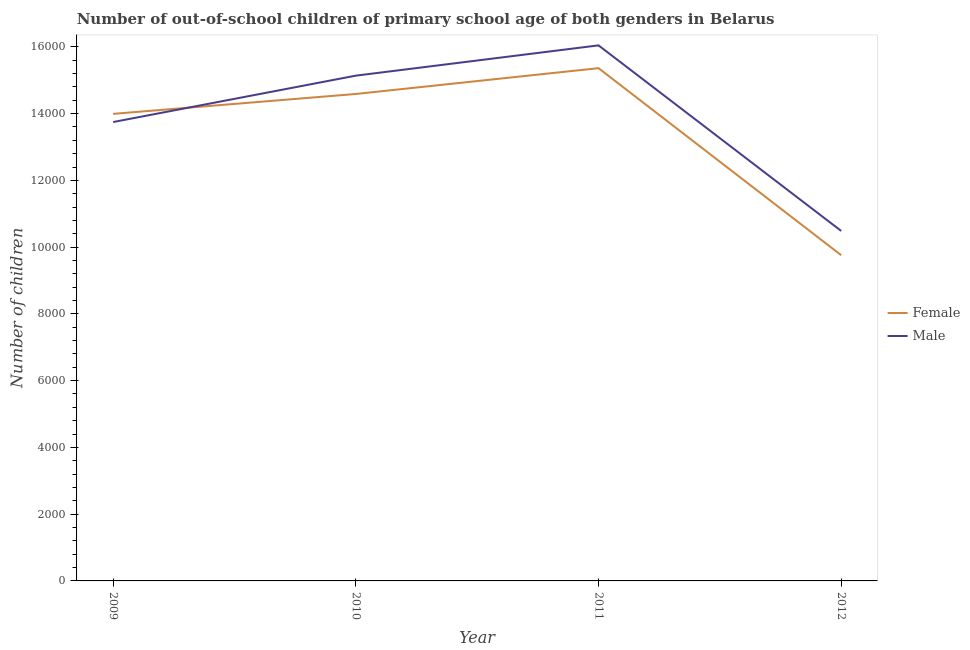Does the line corresponding to number of female out-of-school students intersect with the line corresponding to number of male out-of-school students?
Your response must be concise. Yes. What is the number of male out-of-school students in 2009?
Your response must be concise. 1.37e+04. Across all years, what is the maximum number of male out-of-school students?
Your response must be concise. 1.60e+04. Across all years, what is the minimum number of female out-of-school students?
Keep it short and to the point. 9758. In which year was the number of female out-of-school students maximum?
Ensure brevity in your answer.  2011. In which year was the number of female out-of-school students minimum?
Offer a terse response. 2012. What is the total number of female out-of-school students in the graph?
Your response must be concise. 5.37e+04. What is the difference between the number of male out-of-school students in 2011 and that in 2012?
Give a very brief answer. 5559. What is the difference between the number of female out-of-school students in 2009 and the number of male out-of-school students in 2010?
Your response must be concise. -1145. What is the average number of female out-of-school students per year?
Your answer should be very brief. 1.34e+04. In the year 2010, what is the difference between the number of female out-of-school students and number of male out-of-school students?
Keep it short and to the point. -549. What is the ratio of the number of male out-of-school students in 2011 to that in 2012?
Your answer should be very brief. 1.53. Is the number of male out-of-school students in 2009 less than that in 2012?
Give a very brief answer. No. Is the difference between the number of male out-of-school students in 2011 and 2012 greater than the difference between the number of female out-of-school students in 2011 and 2012?
Offer a terse response. No. What is the difference between the highest and the second highest number of male out-of-school students?
Provide a succinct answer. 907. What is the difference between the highest and the lowest number of male out-of-school students?
Provide a short and direct response. 5559. Is the sum of the number of female out-of-school students in 2009 and 2010 greater than the maximum number of male out-of-school students across all years?
Your response must be concise. Yes. Does the number of male out-of-school students monotonically increase over the years?
Offer a very short reply. No. Is the number of female out-of-school students strictly less than the number of male out-of-school students over the years?
Your answer should be very brief. No. How many lines are there?
Your answer should be very brief. 2. How many years are there in the graph?
Ensure brevity in your answer.  4. What is the difference between two consecutive major ticks on the Y-axis?
Provide a succinct answer. 2000. Are the values on the major ticks of Y-axis written in scientific E-notation?
Make the answer very short. No. Does the graph contain grids?
Your answer should be compact. No. How many legend labels are there?
Ensure brevity in your answer.  2. How are the legend labels stacked?
Provide a succinct answer. Vertical. What is the title of the graph?
Make the answer very short. Number of out-of-school children of primary school age of both genders in Belarus. What is the label or title of the X-axis?
Your response must be concise. Year. What is the label or title of the Y-axis?
Offer a terse response. Number of children. What is the Number of children of Female in 2009?
Offer a terse response. 1.40e+04. What is the Number of children in Male in 2009?
Give a very brief answer. 1.37e+04. What is the Number of children in Female in 2010?
Your answer should be compact. 1.46e+04. What is the Number of children of Male in 2010?
Make the answer very short. 1.51e+04. What is the Number of children in Female in 2011?
Your answer should be compact. 1.54e+04. What is the Number of children in Male in 2011?
Provide a short and direct response. 1.60e+04. What is the Number of children in Female in 2012?
Your answer should be compact. 9758. What is the Number of children in Male in 2012?
Provide a short and direct response. 1.05e+04. Across all years, what is the maximum Number of children in Female?
Make the answer very short. 1.54e+04. Across all years, what is the maximum Number of children in Male?
Keep it short and to the point. 1.60e+04. Across all years, what is the minimum Number of children in Female?
Offer a terse response. 9758. Across all years, what is the minimum Number of children of Male?
Your answer should be compact. 1.05e+04. What is the total Number of children in Female in the graph?
Ensure brevity in your answer.  5.37e+04. What is the total Number of children of Male in the graph?
Keep it short and to the point. 5.54e+04. What is the difference between the Number of children of Female in 2009 and that in 2010?
Make the answer very short. -596. What is the difference between the Number of children of Male in 2009 and that in 2010?
Provide a succinct answer. -1390. What is the difference between the Number of children of Female in 2009 and that in 2011?
Offer a very short reply. -1369. What is the difference between the Number of children of Male in 2009 and that in 2011?
Make the answer very short. -2297. What is the difference between the Number of children of Female in 2009 and that in 2012?
Make the answer very short. 4234. What is the difference between the Number of children in Male in 2009 and that in 2012?
Ensure brevity in your answer.  3262. What is the difference between the Number of children in Female in 2010 and that in 2011?
Keep it short and to the point. -773. What is the difference between the Number of children in Male in 2010 and that in 2011?
Offer a very short reply. -907. What is the difference between the Number of children of Female in 2010 and that in 2012?
Keep it short and to the point. 4830. What is the difference between the Number of children in Male in 2010 and that in 2012?
Keep it short and to the point. 4652. What is the difference between the Number of children of Female in 2011 and that in 2012?
Provide a short and direct response. 5603. What is the difference between the Number of children in Male in 2011 and that in 2012?
Your answer should be very brief. 5559. What is the difference between the Number of children of Female in 2009 and the Number of children of Male in 2010?
Provide a succinct answer. -1145. What is the difference between the Number of children of Female in 2009 and the Number of children of Male in 2011?
Your response must be concise. -2052. What is the difference between the Number of children of Female in 2009 and the Number of children of Male in 2012?
Your response must be concise. 3507. What is the difference between the Number of children in Female in 2010 and the Number of children in Male in 2011?
Provide a succinct answer. -1456. What is the difference between the Number of children of Female in 2010 and the Number of children of Male in 2012?
Provide a succinct answer. 4103. What is the difference between the Number of children in Female in 2011 and the Number of children in Male in 2012?
Give a very brief answer. 4876. What is the average Number of children of Female per year?
Make the answer very short. 1.34e+04. What is the average Number of children of Male per year?
Give a very brief answer. 1.39e+04. In the year 2009, what is the difference between the Number of children in Female and Number of children in Male?
Give a very brief answer. 245. In the year 2010, what is the difference between the Number of children of Female and Number of children of Male?
Your answer should be compact. -549. In the year 2011, what is the difference between the Number of children in Female and Number of children in Male?
Offer a very short reply. -683. In the year 2012, what is the difference between the Number of children in Female and Number of children in Male?
Offer a terse response. -727. What is the ratio of the Number of children of Female in 2009 to that in 2010?
Give a very brief answer. 0.96. What is the ratio of the Number of children in Male in 2009 to that in 2010?
Your response must be concise. 0.91. What is the ratio of the Number of children in Female in 2009 to that in 2011?
Offer a very short reply. 0.91. What is the ratio of the Number of children of Male in 2009 to that in 2011?
Your response must be concise. 0.86. What is the ratio of the Number of children in Female in 2009 to that in 2012?
Make the answer very short. 1.43. What is the ratio of the Number of children of Male in 2009 to that in 2012?
Your answer should be very brief. 1.31. What is the ratio of the Number of children of Female in 2010 to that in 2011?
Your answer should be compact. 0.95. What is the ratio of the Number of children of Male in 2010 to that in 2011?
Your response must be concise. 0.94. What is the ratio of the Number of children of Female in 2010 to that in 2012?
Your answer should be compact. 1.5. What is the ratio of the Number of children of Male in 2010 to that in 2012?
Provide a short and direct response. 1.44. What is the ratio of the Number of children of Female in 2011 to that in 2012?
Keep it short and to the point. 1.57. What is the ratio of the Number of children of Male in 2011 to that in 2012?
Make the answer very short. 1.53. What is the difference between the highest and the second highest Number of children in Female?
Ensure brevity in your answer.  773. What is the difference between the highest and the second highest Number of children of Male?
Your response must be concise. 907. What is the difference between the highest and the lowest Number of children of Female?
Provide a short and direct response. 5603. What is the difference between the highest and the lowest Number of children of Male?
Give a very brief answer. 5559. 